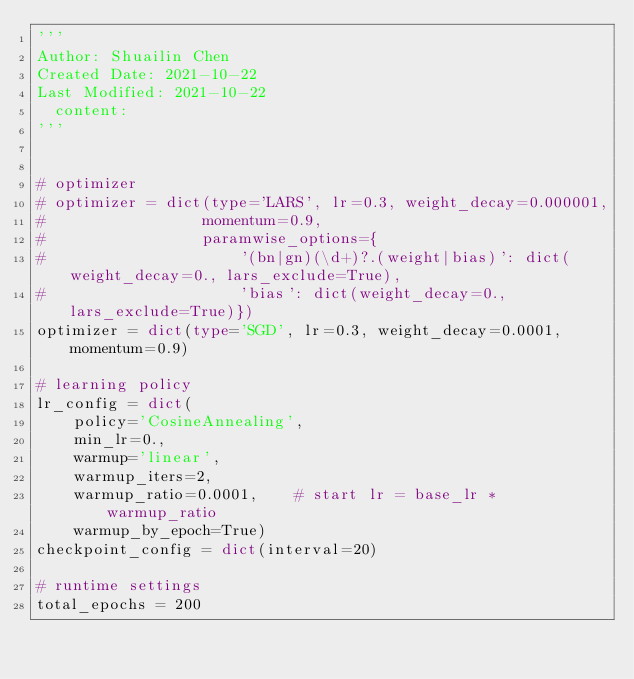<code> <loc_0><loc_0><loc_500><loc_500><_Python_>'''
Author: Shuailin Chen
Created Date: 2021-10-22
Last Modified: 2021-10-22
	content: 
'''


# optimizer
# optimizer = dict(type='LARS', lr=0.3, weight_decay=0.000001, 
#                 momentum=0.9,
#                 paramwise_options={
#                     '(bn|gn)(\d+)?.(weight|bias)': dict(weight_decay=0., lars_exclude=True),
#                     'bias': dict(weight_decay=0., lars_exclude=True)})
optimizer = dict(type='SGD', lr=0.3, weight_decay=0.0001, momentum=0.9)
                    
# learning policy
lr_config = dict(
    policy='CosineAnnealing',
    min_lr=0.,
    warmup='linear',
    warmup_iters=2,
    warmup_ratio=0.0001,    # start lr = base_lr * warmup_ratio
    warmup_by_epoch=True)
checkpoint_config = dict(interval=20)

# runtime settings
total_epochs = 200</code> 